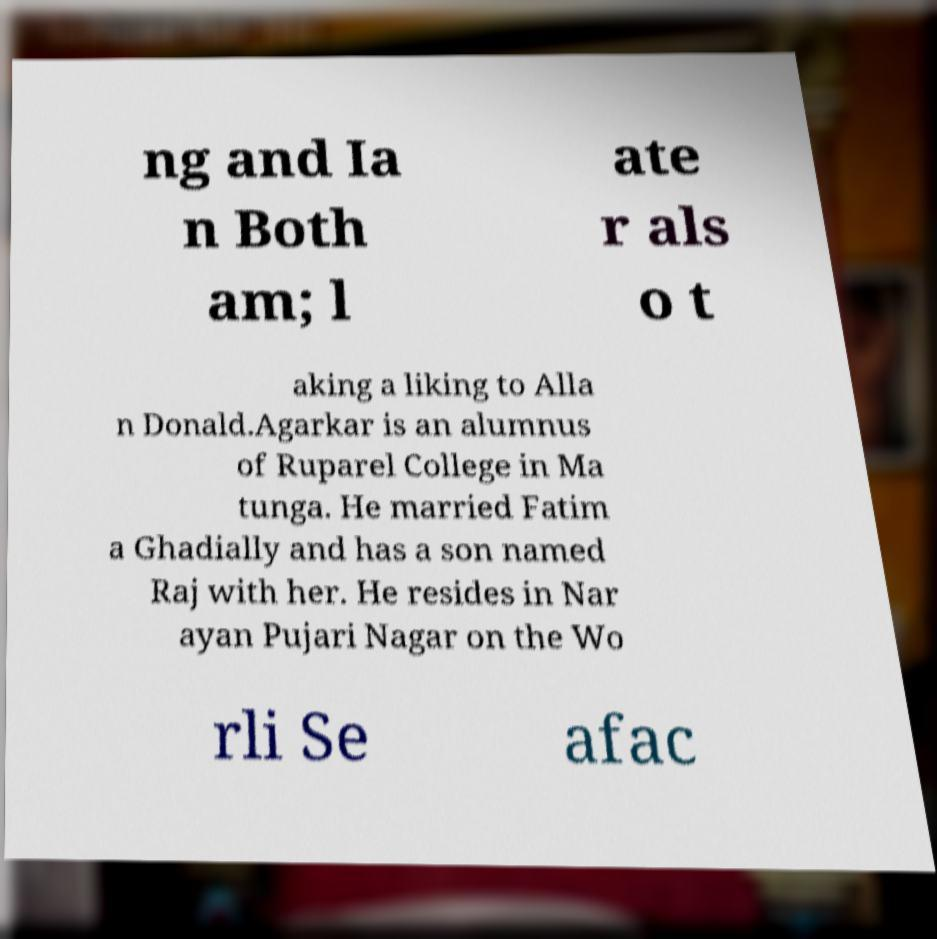I need the written content from this picture converted into text. Can you do that? ng and Ia n Both am; l ate r als o t aking a liking to Alla n Donald.Agarkar is an alumnus of Ruparel College in Ma tunga. He married Fatim a Ghadially and has a son named Raj with her. He resides in Nar ayan Pujari Nagar on the Wo rli Se afac 